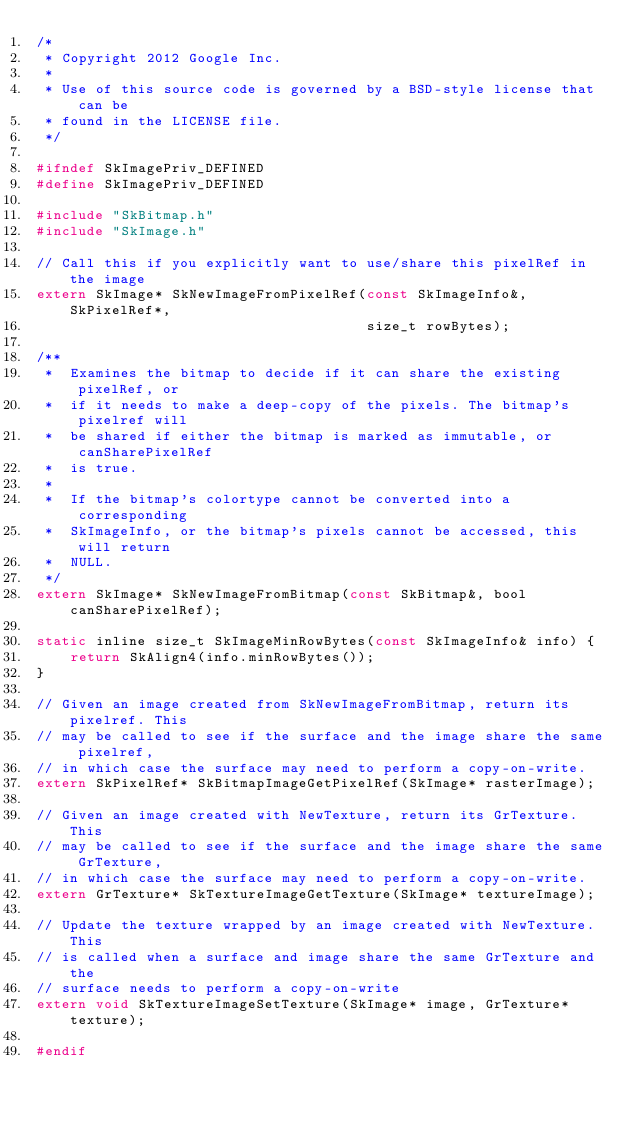Convert code to text. <code><loc_0><loc_0><loc_500><loc_500><_C_>/*
 * Copyright 2012 Google Inc.
 *
 * Use of this source code is governed by a BSD-style license that can be
 * found in the LICENSE file.
 */

#ifndef SkImagePriv_DEFINED
#define SkImagePriv_DEFINED

#include "SkBitmap.h"
#include "SkImage.h"

// Call this if you explicitly want to use/share this pixelRef in the image
extern SkImage* SkNewImageFromPixelRef(const SkImageInfo&, SkPixelRef*,
                                       size_t rowBytes);

/**
 *  Examines the bitmap to decide if it can share the existing pixelRef, or
 *  if it needs to make a deep-copy of the pixels. The bitmap's pixelref will
 *  be shared if either the bitmap is marked as immutable, or canSharePixelRef
 *  is true.
 *
 *  If the bitmap's colortype cannot be converted into a corresponding
 *  SkImageInfo, or the bitmap's pixels cannot be accessed, this will return
 *  NULL.
 */
extern SkImage* SkNewImageFromBitmap(const SkBitmap&, bool canSharePixelRef);

static inline size_t SkImageMinRowBytes(const SkImageInfo& info) {
    return SkAlign4(info.minRowBytes());
}

// Given an image created from SkNewImageFromBitmap, return its pixelref. This
// may be called to see if the surface and the image share the same pixelref,
// in which case the surface may need to perform a copy-on-write.
extern SkPixelRef* SkBitmapImageGetPixelRef(SkImage* rasterImage);

// Given an image created with NewTexture, return its GrTexture. This
// may be called to see if the surface and the image share the same GrTexture,
// in which case the surface may need to perform a copy-on-write.
extern GrTexture* SkTextureImageGetTexture(SkImage* textureImage);

// Update the texture wrapped by an image created with NewTexture. This
// is called when a surface and image share the same GrTexture and the
// surface needs to perform a copy-on-write
extern void SkTextureImageSetTexture(SkImage* image, GrTexture* texture);

#endif
</code> 